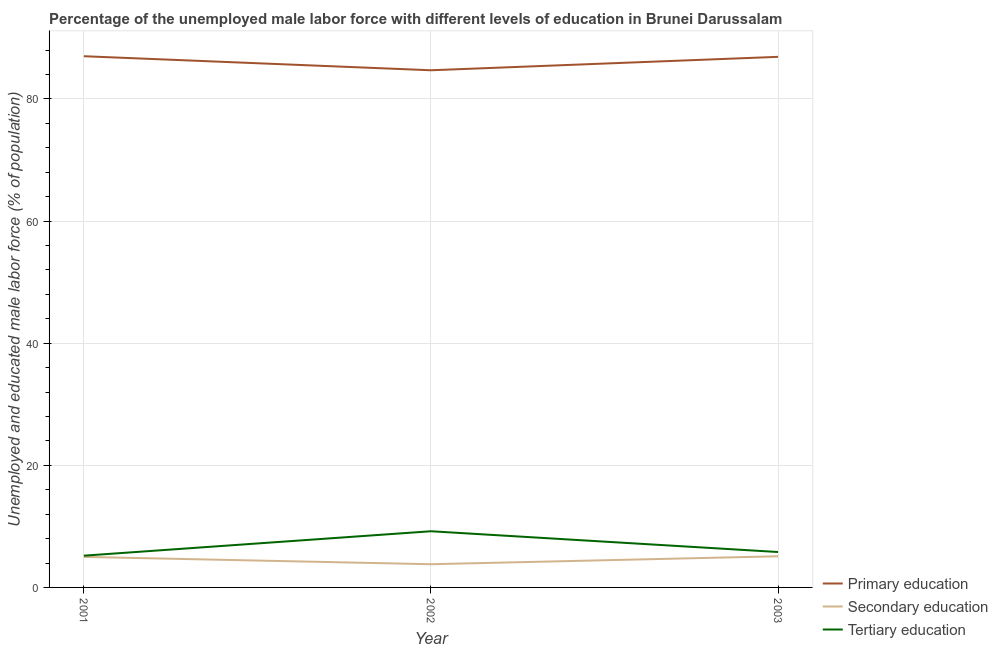Does the line corresponding to percentage of male labor force who received primary education intersect with the line corresponding to percentage of male labor force who received secondary education?
Keep it short and to the point. No. What is the percentage of male labor force who received primary education in 2002?
Keep it short and to the point. 84.7. Across all years, what is the minimum percentage of male labor force who received primary education?
Your response must be concise. 84.7. In which year was the percentage of male labor force who received primary education minimum?
Your answer should be compact. 2002. What is the total percentage of male labor force who received primary education in the graph?
Offer a terse response. 258.6. What is the difference between the percentage of male labor force who received secondary education in 2001 and that in 2002?
Your answer should be very brief. 1.2. What is the difference between the percentage of male labor force who received secondary education in 2003 and the percentage of male labor force who received primary education in 2002?
Keep it short and to the point. -79.6. What is the average percentage of male labor force who received secondary education per year?
Provide a short and direct response. 4.63. In the year 2001, what is the difference between the percentage of male labor force who received primary education and percentage of male labor force who received tertiary education?
Your answer should be compact. 81.8. In how many years, is the percentage of male labor force who received primary education greater than 32 %?
Ensure brevity in your answer.  3. What is the ratio of the percentage of male labor force who received secondary education in 2001 to that in 2003?
Provide a short and direct response. 0.98. Is the percentage of male labor force who received primary education in 2001 less than that in 2003?
Keep it short and to the point. No. Is the difference between the percentage of male labor force who received secondary education in 2001 and 2003 greater than the difference between the percentage of male labor force who received primary education in 2001 and 2003?
Make the answer very short. No. What is the difference between the highest and the second highest percentage of male labor force who received tertiary education?
Your answer should be very brief. 3.4. What is the difference between the highest and the lowest percentage of male labor force who received primary education?
Your response must be concise. 2.3. Is the sum of the percentage of male labor force who received tertiary education in 2002 and 2003 greater than the maximum percentage of male labor force who received primary education across all years?
Keep it short and to the point. No. How many lines are there?
Your answer should be compact. 3. How many years are there in the graph?
Your answer should be very brief. 3. How many legend labels are there?
Provide a succinct answer. 3. How are the legend labels stacked?
Provide a short and direct response. Vertical. What is the title of the graph?
Your answer should be very brief. Percentage of the unemployed male labor force with different levels of education in Brunei Darussalam. What is the label or title of the Y-axis?
Your answer should be very brief. Unemployed and educated male labor force (% of population). What is the Unemployed and educated male labor force (% of population) of Primary education in 2001?
Keep it short and to the point. 87. What is the Unemployed and educated male labor force (% of population) of Secondary education in 2001?
Provide a short and direct response. 5. What is the Unemployed and educated male labor force (% of population) of Tertiary education in 2001?
Provide a succinct answer. 5.2. What is the Unemployed and educated male labor force (% of population) of Primary education in 2002?
Your answer should be compact. 84.7. What is the Unemployed and educated male labor force (% of population) of Secondary education in 2002?
Provide a short and direct response. 3.8. What is the Unemployed and educated male labor force (% of population) in Tertiary education in 2002?
Give a very brief answer. 9.2. What is the Unemployed and educated male labor force (% of population) in Primary education in 2003?
Your answer should be compact. 86.9. What is the Unemployed and educated male labor force (% of population) in Secondary education in 2003?
Give a very brief answer. 5.1. What is the Unemployed and educated male labor force (% of population) in Tertiary education in 2003?
Keep it short and to the point. 5.8. Across all years, what is the maximum Unemployed and educated male labor force (% of population) of Primary education?
Give a very brief answer. 87. Across all years, what is the maximum Unemployed and educated male labor force (% of population) of Secondary education?
Give a very brief answer. 5.1. Across all years, what is the maximum Unemployed and educated male labor force (% of population) of Tertiary education?
Ensure brevity in your answer.  9.2. Across all years, what is the minimum Unemployed and educated male labor force (% of population) of Primary education?
Your answer should be very brief. 84.7. Across all years, what is the minimum Unemployed and educated male labor force (% of population) of Secondary education?
Ensure brevity in your answer.  3.8. Across all years, what is the minimum Unemployed and educated male labor force (% of population) in Tertiary education?
Your answer should be very brief. 5.2. What is the total Unemployed and educated male labor force (% of population) in Primary education in the graph?
Offer a very short reply. 258.6. What is the total Unemployed and educated male labor force (% of population) of Tertiary education in the graph?
Provide a short and direct response. 20.2. What is the difference between the Unemployed and educated male labor force (% of population) in Secondary education in 2001 and that in 2002?
Keep it short and to the point. 1.2. What is the difference between the Unemployed and educated male labor force (% of population) of Tertiary education in 2001 and that in 2002?
Give a very brief answer. -4. What is the difference between the Unemployed and educated male labor force (% of population) in Primary education in 2001 and that in 2003?
Provide a succinct answer. 0.1. What is the difference between the Unemployed and educated male labor force (% of population) in Tertiary education in 2001 and that in 2003?
Offer a terse response. -0.6. What is the difference between the Unemployed and educated male labor force (% of population) in Primary education in 2002 and that in 2003?
Ensure brevity in your answer.  -2.2. What is the difference between the Unemployed and educated male labor force (% of population) of Secondary education in 2002 and that in 2003?
Make the answer very short. -1.3. What is the difference between the Unemployed and educated male labor force (% of population) in Tertiary education in 2002 and that in 2003?
Provide a short and direct response. 3.4. What is the difference between the Unemployed and educated male labor force (% of population) of Primary education in 2001 and the Unemployed and educated male labor force (% of population) of Secondary education in 2002?
Your answer should be compact. 83.2. What is the difference between the Unemployed and educated male labor force (% of population) of Primary education in 2001 and the Unemployed and educated male labor force (% of population) of Tertiary education in 2002?
Your answer should be very brief. 77.8. What is the difference between the Unemployed and educated male labor force (% of population) of Secondary education in 2001 and the Unemployed and educated male labor force (% of population) of Tertiary education in 2002?
Ensure brevity in your answer.  -4.2. What is the difference between the Unemployed and educated male labor force (% of population) in Primary education in 2001 and the Unemployed and educated male labor force (% of population) in Secondary education in 2003?
Ensure brevity in your answer.  81.9. What is the difference between the Unemployed and educated male labor force (% of population) in Primary education in 2001 and the Unemployed and educated male labor force (% of population) in Tertiary education in 2003?
Your response must be concise. 81.2. What is the difference between the Unemployed and educated male labor force (% of population) in Secondary education in 2001 and the Unemployed and educated male labor force (% of population) in Tertiary education in 2003?
Give a very brief answer. -0.8. What is the difference between the Unemployed and educated male labor force (% of population) in Primary education in 2002 and the Unemployed and educated male labor force (% of population) in Secondary education in 2003?
Ensure brevity in your answer.  79.6. What is the difference between the Unemployed and educated male labor force (% of population) of Primary education in 2002 and the Unemployed and educated male labor force (% of population) of Tertiary education in 2003?
Your answer should be compact. 78.9. What is the average Unemployed and educated male labor force (% of population) of Primary education per year?
Offer a terse response. 86.2. What is the average Unemployed and educated male labor force (% of population) in Secondary education per year?
Your answer should be compact. 4.63. What is the average Unemployed and educated male labor force (% of population) of Tertiary education per year?
Provide a short and direct response. 6.73. In the year 2001, what is the difference between the Unemployed and educated male labor force (% of population) in Primary education and Unemployed and educated male labor force (% of population) in Tertiary education?
Keep it short and to the point. 81.8. In the year 2001, what is the difference between the Unemployed and educated male labor force (% of population) in Secondary education and Unemployed and educated male labor force (% of population) in Tertiary education?
Keep it short and to the point. -0.2. In the year 2002, what is the difference between the Unemployed and educated male labor force (% of population) in Primary education and Unemployed and educated male labor force (% of population) in Secondary education?
Your answer should be compact. 80.9. In the year 2002, what is the difference between the Unemployed and educated male labor force (% of population) of Primary education and Unemployed and educated male labor force (% of population) of Tertiary education?
Provide a short and direct response. 75.5. In the year 2002, what is the difference between the Unemployed and educated male labor force (% of population) in Secondary education and Unemployed and educated male labor force (% of population) in Tertiary education?
Keep it short and to the point. -5.4. In the year 2003, what is the difference between the Unemployed and educated male labor force (% of population) of Primary education and Unemployed and educated male labor force (% of population) of Secondary education?
Your response must be concise. 81.8. In the year 2003, what is the difference between the Unemployed and educated male labor force (% of population) in Primary education and Unemployed and educated male labor force (% of population) in Tertiary education?
Give a very brief answer. 81.1. In the year 2003, what is the difference between the Unemployed and educated male labor force (% of population) in Secondary education and Unemployed and educated male labor force (% of population) in Tertiary education?
Offer a very short reply. -0.7. What is the ratio of the Unemployed and educated male labor force (% of population) of Primary education in 2001 to that in 2002?
Provide a short and direct response. 1.03. What is the ratio of the Unemployed and educated male labor force (% of population) in Secondary education in 2001 to that in 2002?
Keep it short and to the point. 1.32. What is the ratio of the Unemployed and educated male labor force (% of population) in Tertiary education in 2001 to that in 2002?
Your response must be concise. 0.57. What is the ratio of the Unemployed and educated male labor force (% of population) in Primary education in 2001 to that in 2003?
Give a very brief answer. 1. What is the ratio of the Unemployed and educated male labor force (% of population) in Secondary education in 2001 to that in 2003?
Offer a very short reply. 0.98. What is the ratio of the Unemployed and educated male labor force (% of population) of Tertiary education in 2001 to that in 2003?
Offer a terse response. 0.9. What is the ratio of the Unemployed and educated male labor force (% of population) in Primary education in 2002 to that in 2003?
Provide a succinct answer. 0.97. What is the ratio of the Unemployed and educated male labor force (% of population) of Secondary education in 2002 to that in 2003?
Offer a terse response. 0.75. What is the ratio of the Unemployed and educated male labor force (% of population) of Tertiary education in 2002 to that in 2003?
Give a very brief answer. 1.59. What is the difference between the highest and the lowest Unemployed and educated male labor force (% of population) of Tertiary education?
Provide a short and direct response. 4. 